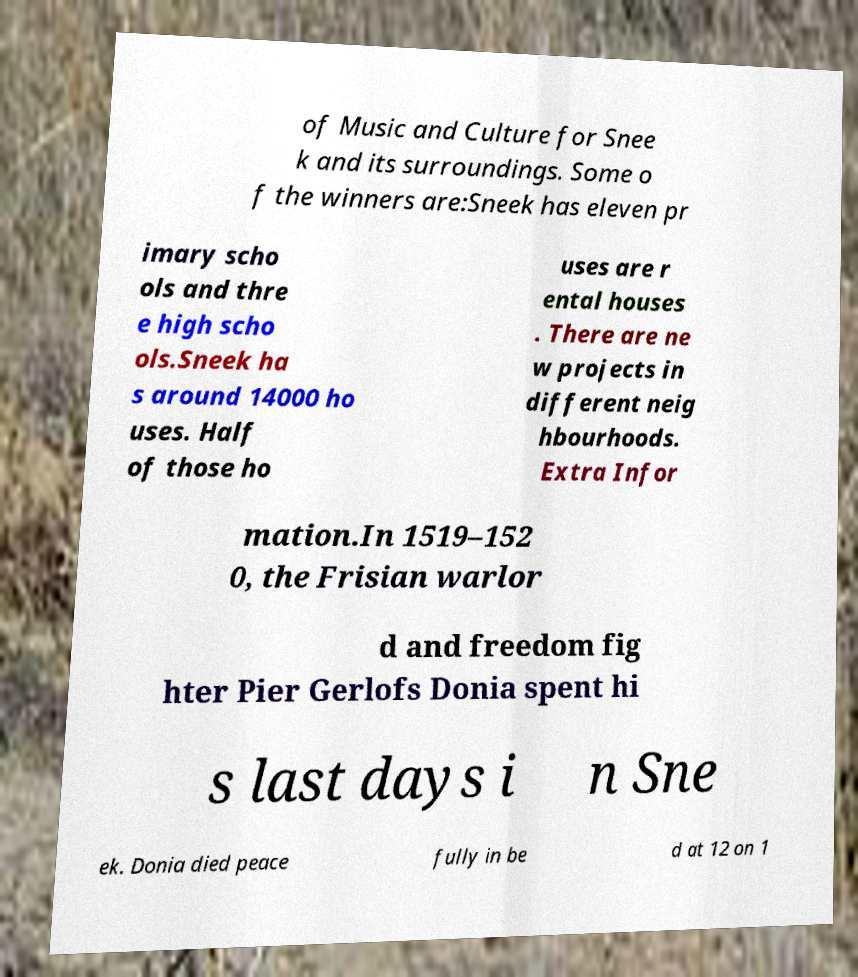Could you extract and type out the text from this image? of Music and Culture for Snee k and its surroundings. Some o f the winners are:Sneek has eleven pr imary scho ols and thre e high scho ols.Sneek ha s around 14000 ho uses. Half of those ho uses are r ental houses . There are ne w projects in different neig hbourhoods. Extra Infor mation.In 1519–152 0, the Frisian warlor d and freedom fig hter Pier Gerlofs Donia spent hi s last days i n Sne ek. Donia died peace fully in be d at 12 on 1 